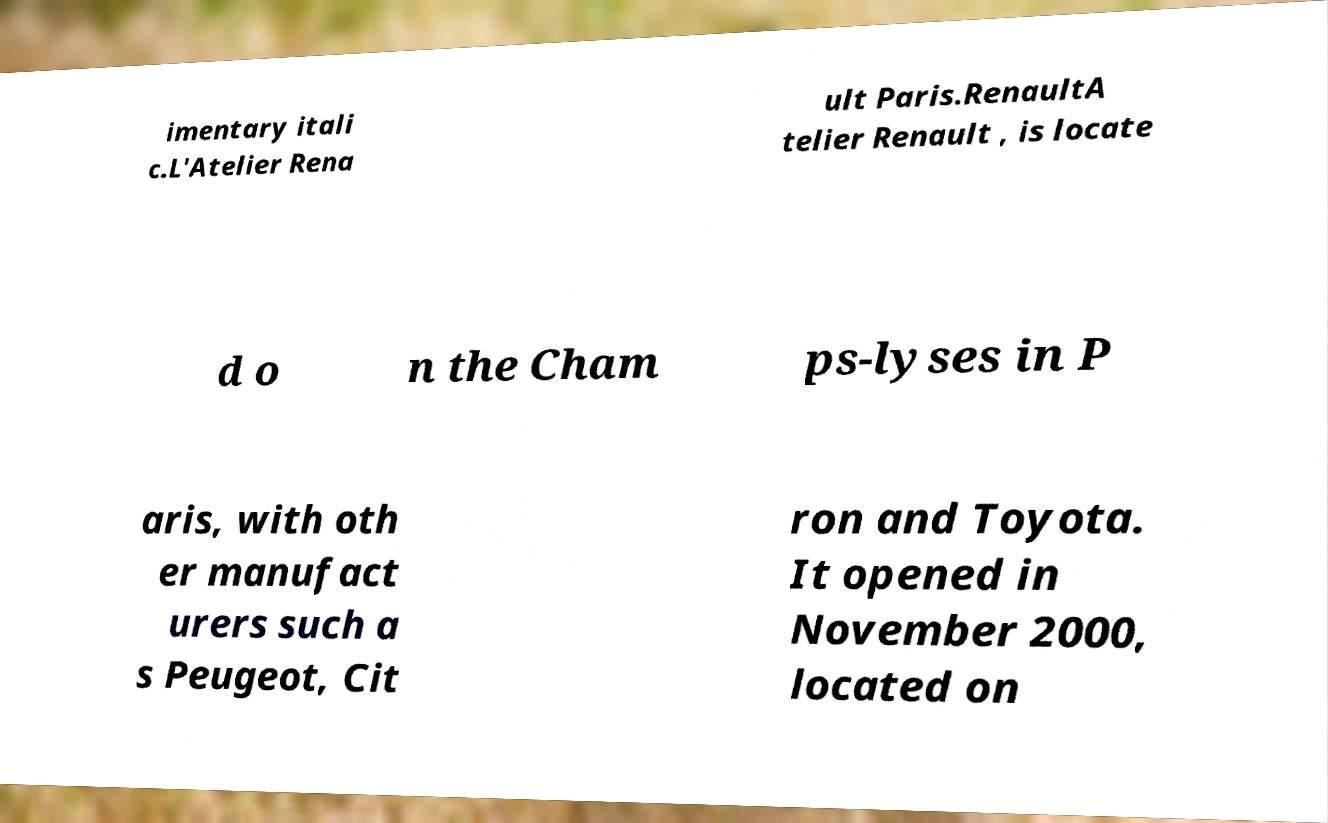There's text embedded in this image that I need extracted. Can you transcribe it verbatim? imentary itali c.L'Atelier Rena ult Paris.RenaultA telier Renault , is locate d o n the Cham ps-lyses in P aris, with oth er manufact urers such a s Peugeot, Cit ron and Toyota. It opened in November 2000, located on 